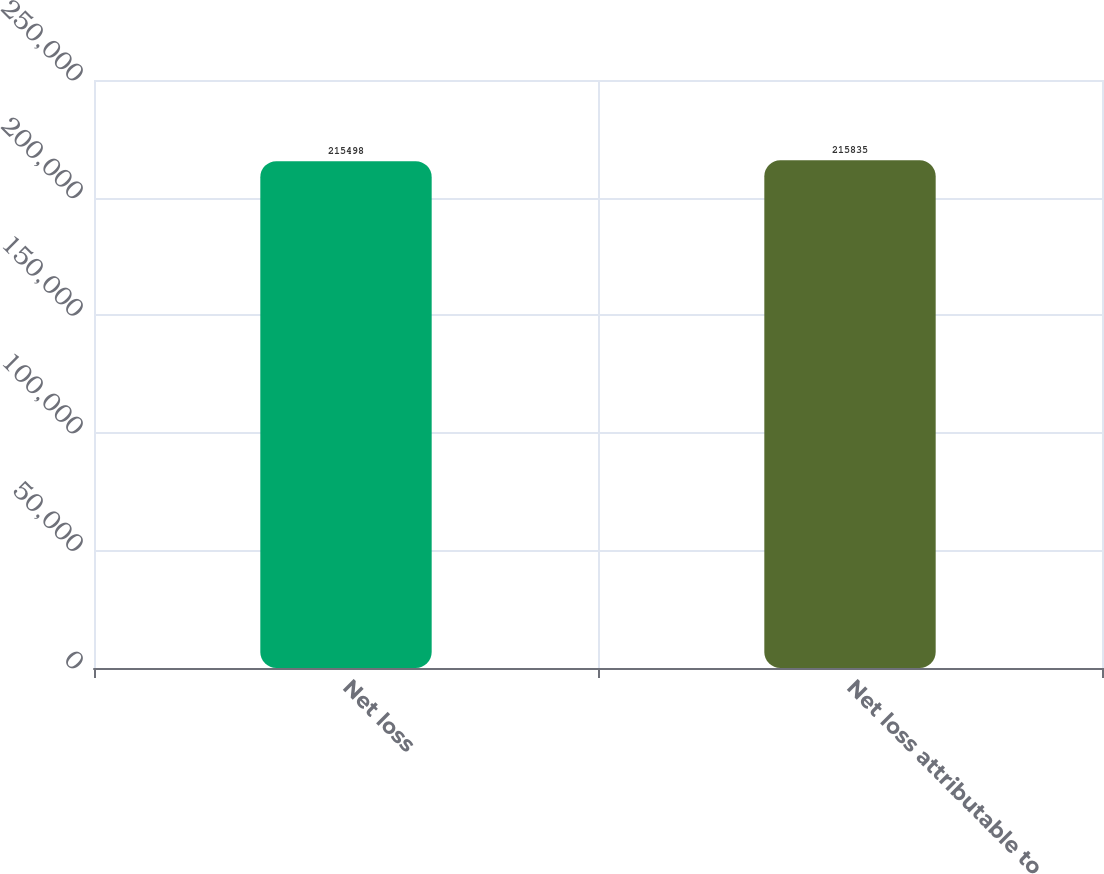<chart> <loc_0><loc_0><loc_500><loc_500><bar_chart><fcel>Net loss<fcel>Net loss attributable to<nl><fcel>215498<fcel>215835<nl></chart> 